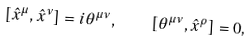Convert formula to latex. <formula><loc_0><loc_0><loc_500><loc_500>\left [ { \hat { x } } ^ { \mu } , { \hat { x } } ^ { \nu } \right ] = i \theta ^ { \mu \nu } , \quad \left [ \theta ^ { \mu \nu } , { \hat { x } } ^ { \rho } \right ] = 0 ,</formula> 